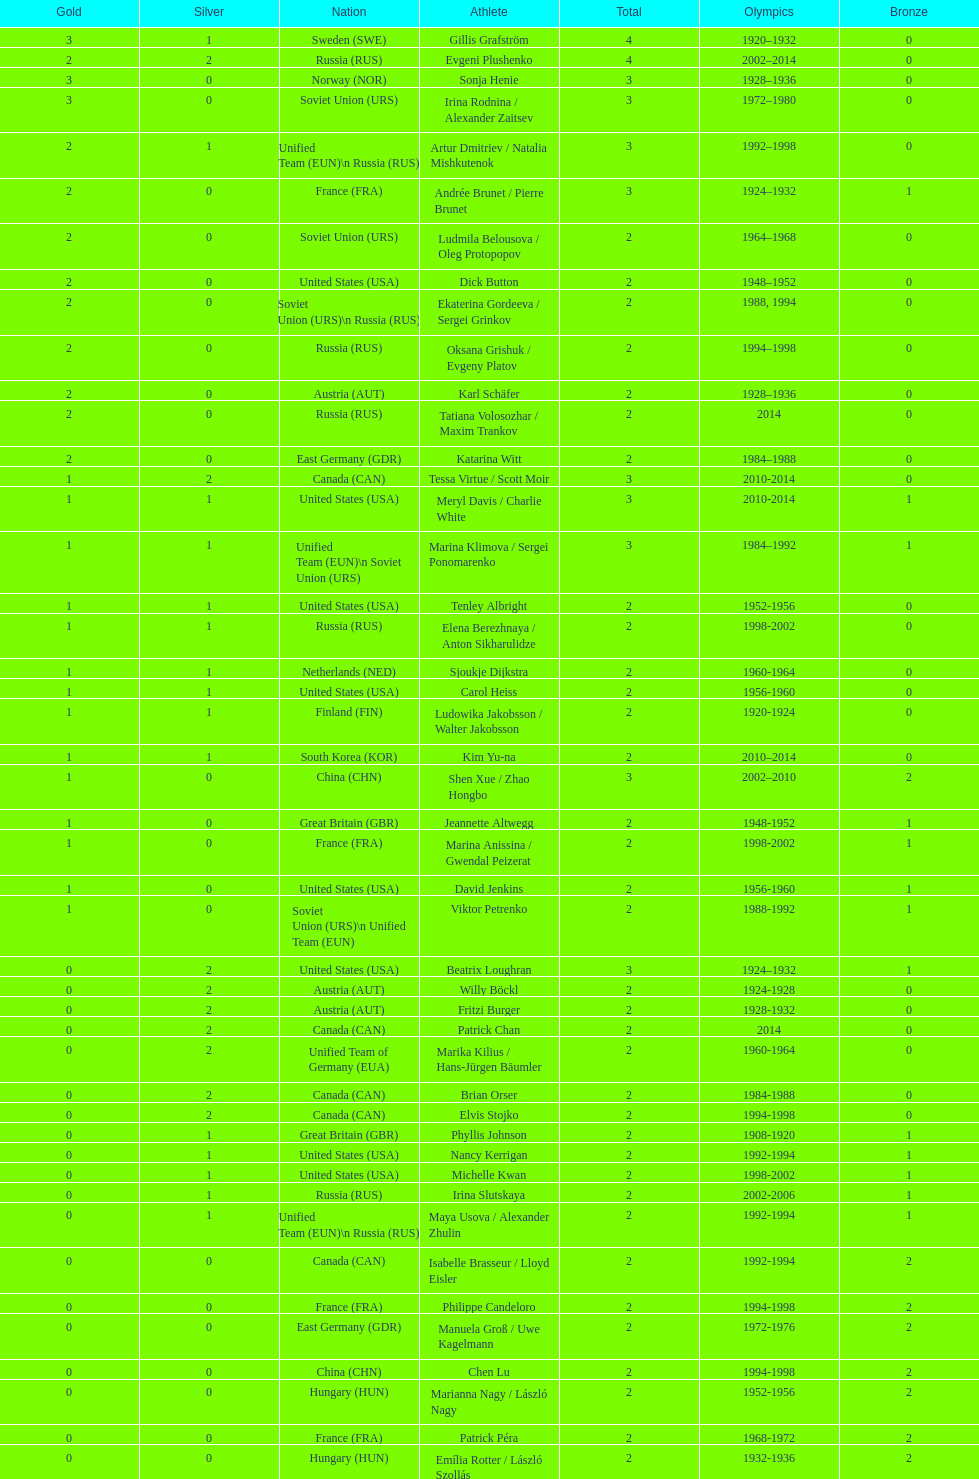Could you help me parse every detail presented in this table? {'header': ['Gold', 'Silver', 'Nation', 'Athlete', 'Total', 'Olympics', 'Bronze'], 'rows': [['3', '1', 'Sweden\xa0(SWE)', 'Gillis Grafström', '4', '1920–1932', '0'], ['2', '2', 'Russia\xa0(RUS)', 'Evgeni Plushenko', '4', '2002–2014', '0'], ['3', '0', 'Norway\xa0(NOR)', 'Sonja Henie', '3', '1928–1936', '0'], ['3', '0', 'Soviet Union\xa0(URS)', 'Irina Rodnina / Alexander Zaitsev', '3', '1972–1980', '0'], ['2', '1', 'Unified Team\xa0(EUN)\\n\xa0Russia\xa0(RUS)', 'Artur Dmitriev / Natalia Mishkutenok', '3', '1992–1998', '0'], ['2', '0', 'France\xa0(FRA)', 'Andrée Brunet / Pierre Brunet', '3', '1924–1932', '1'], ['2', '0', 'Soviet Union\xa0(URS)', 'Ludmila Belousova / Oleg Protopopov', '2', '1964–1968', '0'], ['2', '0', 'United States\xa0(USA)', 'Dick Button', '2', '1948–1952', '0'], ['2', '0', 'Soviet Union\xa0(URS)\\n\xa0Russia\xa0(RUS)', 'Ekaterina Gordeeva / Sergei Grinkov', '2', '1988, 1994', '0'], ['2', '0', 'Russia\xa0(RUS)', 'Oksana Grishuk / Evgeny Platov', '2', '1994–1998', '0'], ['2', '0', 'Austria\xa0(AUT)', 'Karl Schäfer', '2', '1928–1936', '0'], ['2', '0', 'Russia\xa0(RUS)', 'Tatiana Volosozhar / Maxim Trankov', '2', '2014', '0'], ['2', '0', 'East Germany\xa0(GDR)', 'Katarina Witt', '2', '1984–1988', '0'], ['1', '2', 'Canada\xa0(CAN)', 'Tessa Virtue / Scott Moir', '3', '2010-2014', '0'], ['1', '1', 'United States\xa0(USA)', 'Meryl Davis / Charlie White', '3', '2010-2014', '1'], ['1', '1', 'Unified Team\xa0(EUN)\\n\xa0Soviet Union\xa0(URS)', 'Marina Klimova / Sergei Ponomarenko', '3', '1984–1992', '1'], ['1', '1', 'United States\xa0(USA)', 'Tenley Albright', '2', '1952-1956', '0'], ['1', '1', 'Russia\xa0(RUS)', 'Elena Berezhnaya / Anton Sikharulidze', '2', '1998-2002', '0'], ['1', '1', 'Netherlands\xa0(NED)', 'Sjoukje Dijkstra', '2', '1960-1964', '0'], ['1', '1', 'United States\xa0(USA)', 'Carol Heiss', '2', '1956-1960', '0'], ['1', '1', 'Finland\xa0(FIN)', 'Ludowika Jakobsson / Walter Jakobsson', '2', '1920-1924', '0'], ['1', '1', 'South Korea\xa0(KOR)', 'Kim Yu-na', '2', '2010–2014', '0'], ['1', '0', 'China\xa0(CHN)', 'Shen Xue / Zhao Hongbo', '3', '2002–2010', '2'], ['1', '0', 'Great Britain\xa0(GBR)', 'Jeannette Altwegg', '2', '1948-1952', '1'], ['1', '0', 'France\xa0(FRA)', 'Marina Anissina / Gwendal Peizerat', '2', '1998-2002', '1'], ['1', '0', 'United States\xa0(USA)', 'David Jenkins', '2', '1956-1960', '1'], ['1', '0', 'Soviet Union\xa0(URS)\\n\xa0Unified Team\xa0(EUN)', 'Viktor Petrenko', '2', '1988-1992', '1'], ['0', '2', 'United States\xa0(USA)', 'Beatrix Loughran', '3', '1924–1932', '1'], ['0', '2', 'Austria\xa0(AUT)', 'Willy Böckl', '2', '1924-1928', '0'], ['0', '2', 'Austria\xa0(AUT)', 'Fritzi Burger', '2', '1928-1932', '0'], ['0', '2', 'Canada\xa0(CAN)', 'Patrick Chan', '2', '2014', '0'], ['0', '2', 'Unified Team of Germany\xa0(EUA)', 'Marika Kilius / Hans-Jürgen Bäumler', '2', '1960-1964', '0'], ['0', '2', 'Canada\xa0(CAN)', 'Brian Orser', '2', '1984-1988', '0'], ['0', '2', 'Canada\xa0(CAN)', 'Elvis Stojko', '2', '1994-1998', '0'], ['0', '1', 'Great Britain\xa0(GBR)', 'Phyllis Johnson', '2', '1908-1920', '1'], ['0', '1', 'United States\xa0(USA)', 'Nancy Kerrigan', '2', '1992-1994', '1'], ['0', '1', 'United States\xa0(USA)', 'Michelle Kwan', '2', '1998-2002', '1'], ['0', '1', 'Russia\xa0(RUS)', 'Irina Slutskaya', '2', '2002-2006', '1'], ['0', '1', 'Unified Team\xa0(EUN)\\n\xa0Russia\xa0(RUS)', 'Maya Usova / Alexander Zhulin', '2', '1992-1994', '1'], ['0', '0', 'Canada\xa0(CAN)', 'Isabelle Brasseur / Lloyd Eisler', '2', '1992-1994', '2'], ['0', '0', 'France\xa0(FRA)', 'Philippe Candeloro', '2', '1994-1998', '2'], ['0', '0', 'East Germany\xa0(GDR)', 'Manuela Groß / Uwe Kagelmann', '2', '1972-1976', '2'], ['0', '0', 'China\xa0(CHN)', 'Chen Lu', '2', '1994-1998', '2'], ['0', '0', 'Hungary\xa0(HUN)', 'Marianna Nagy / László Nagy', '2', '1952-1956', '2'], ['0', '0', 'France\xa0(FRA)', 'Patrick Péra', '2', '1968-1972', '2'], ['0', '0', 'Hungary\xa0(HUN)', 'Emília Rotter / László Szollás', '2', '1932-1936', '2'], ['0', '0', 'Germany\xa0(GER)', 'Aliona Savchenko / Robin Szolkowy', '2', '2010-2014', '2']]} How many medals have sweden and norway won combined? 7. 